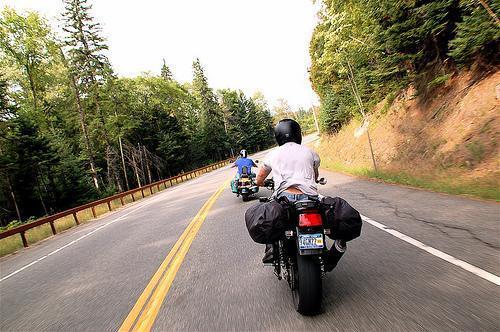How many people are riding bikes on the road?
Give a very brief answer. 0. 